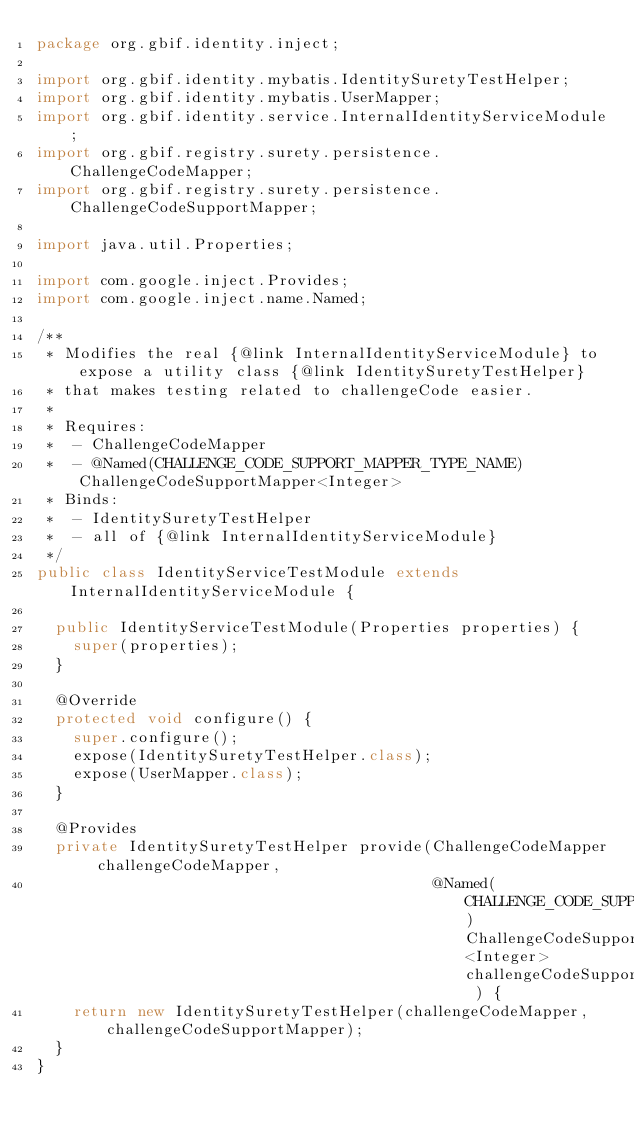<code> <loc_0><loc_0><loc_500><loc_500><_Java_>package org.gbif.identity.inject;

import org.gbif.identity.mybatis.IdentitySuretyTestHelper;
import org.gbif.identity.mybatis.UserMapper;
import org.gbif.identity.service.InternalIdentityServiceModule;
import org.gbif.registry.surety.persistence.ChallengeCodeMapper;
import org.gbif.registry.surety.persistence.ChallengeCodeSupportMapper;

import java.util.Properties;

import com.google.inject.Provides;
import com.google.inject.name.Named;

/**
 * Modifies the real {@link InternalIdentityServiceModule} to expose a utility class {@link IdentitySuretyTestHelper}
 * that makes testing related to challengeCode easier.
 *
 * Requires:
 *  - ChallengeCodeMapper
 *  - @Named(CHALLENGE_CODE_SUPPORT_MAPPER_TYPE_NAME) ChallengeCodeSupportMapper<Integer>
 * Binds:
 *  - IdentitySuretyTestHelper
 *  - all of {@link InternalIdentityServiceModule}
 */
public class IdentityServiceTestModule extends InternalIdentityServiceModule {

  public IdentityServiceTestModule(Properties properties) {
    super(properties);
  }

  @Override
  protected void configure() {
    super.configure();
    expose(IdentitySuretyTestHelper.class);
    expose(UserMapper.class);
  }

  @Provides
  private IdentitySuretyTestHelper provide(ChallengeCodeMapper challengeCodeMapper,
                                           @Named(CHALLENGE_CODE_SUPPORT_MAPPER_TYPE_NAME) ChallengeCodeSupportMapper<Integer> challengeCodeSupportMapper ) {
    return new IdentitySuretyTestHelper(challengeCodeMapper, challengeCodeSupportMapper);
  }
}</code> 